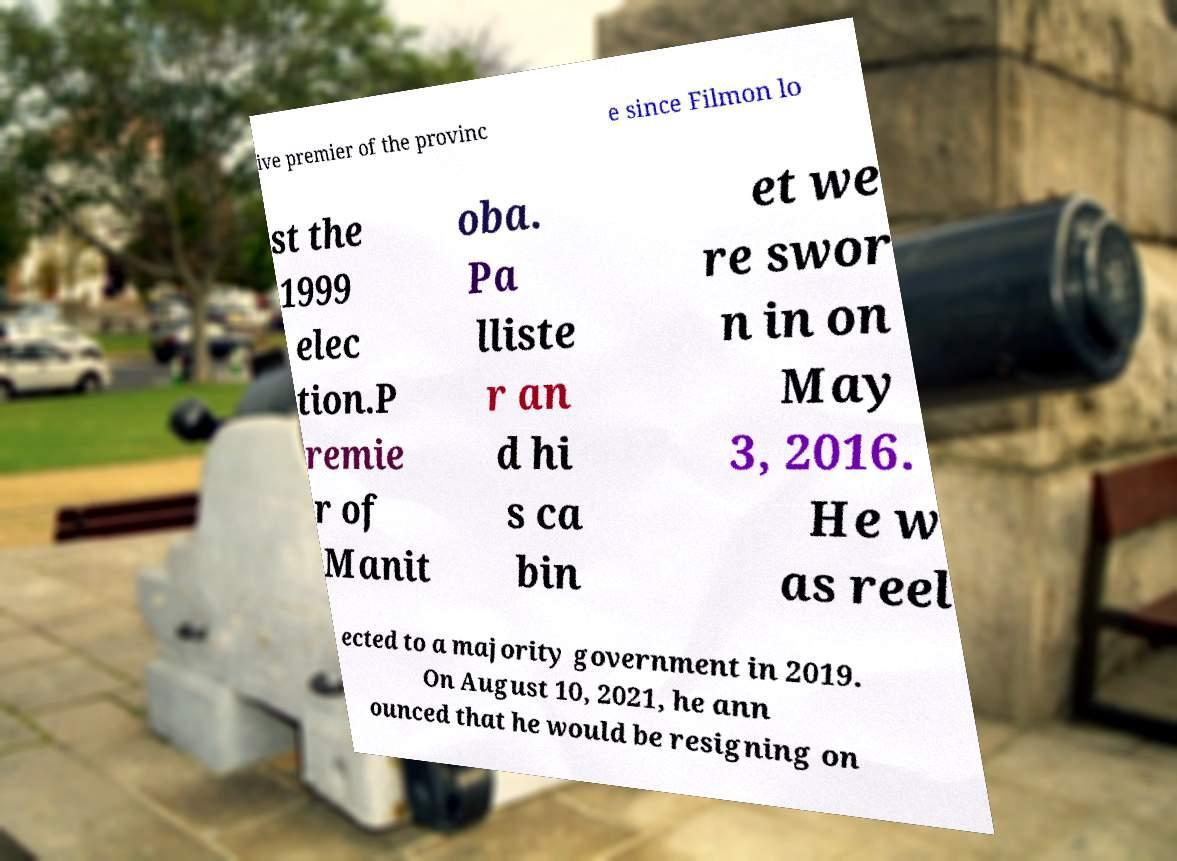Can you accurately transcribe the text from the provided image for me? ive premier of the provinc e since Filmon lo st the 1999 elec tion.P remie r of Manit oba. Pa lliste r an d hi s ca bin et we re swor n in on May 3, 2016. He w as reel ected to a majority government in 2019. On August 10, 2021, he ann ounced that he would be resigning on 